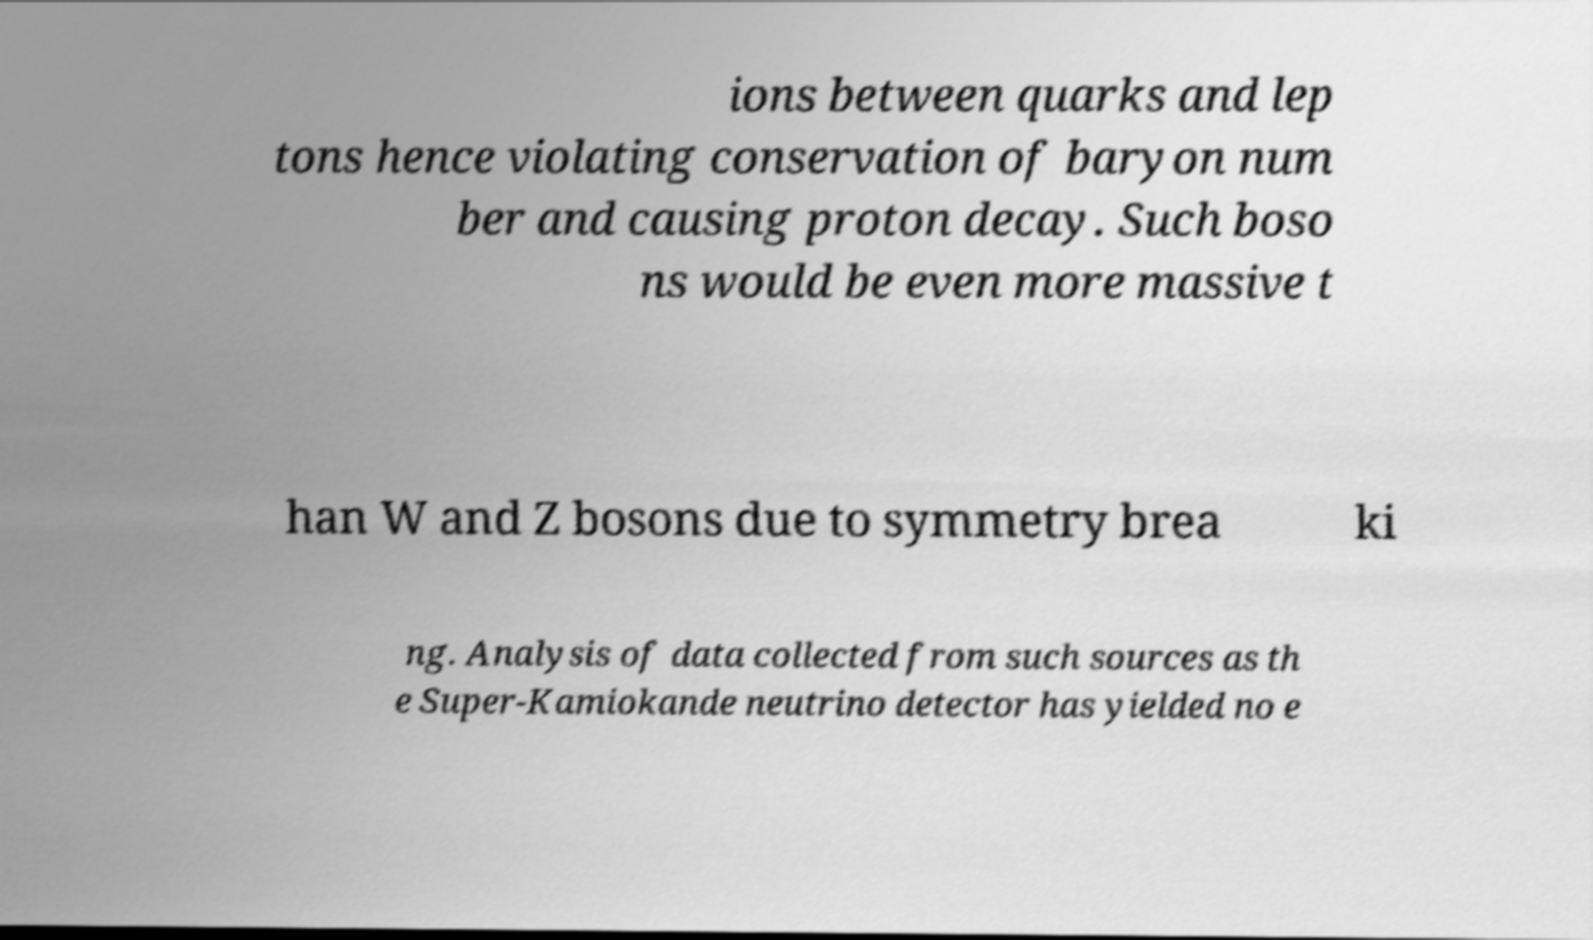Can you accurately transcribe the text from the provided image for me? ions between quarks and lep tons hence violating conservation of baryon num ber and causing proton decay. Such boso ns would be even more massive t han W and Z bosons due to symmetry brea ki ng. Analysis of data collected from such sources as th e Super-Kamiokande neutrino detector has yielded no e 